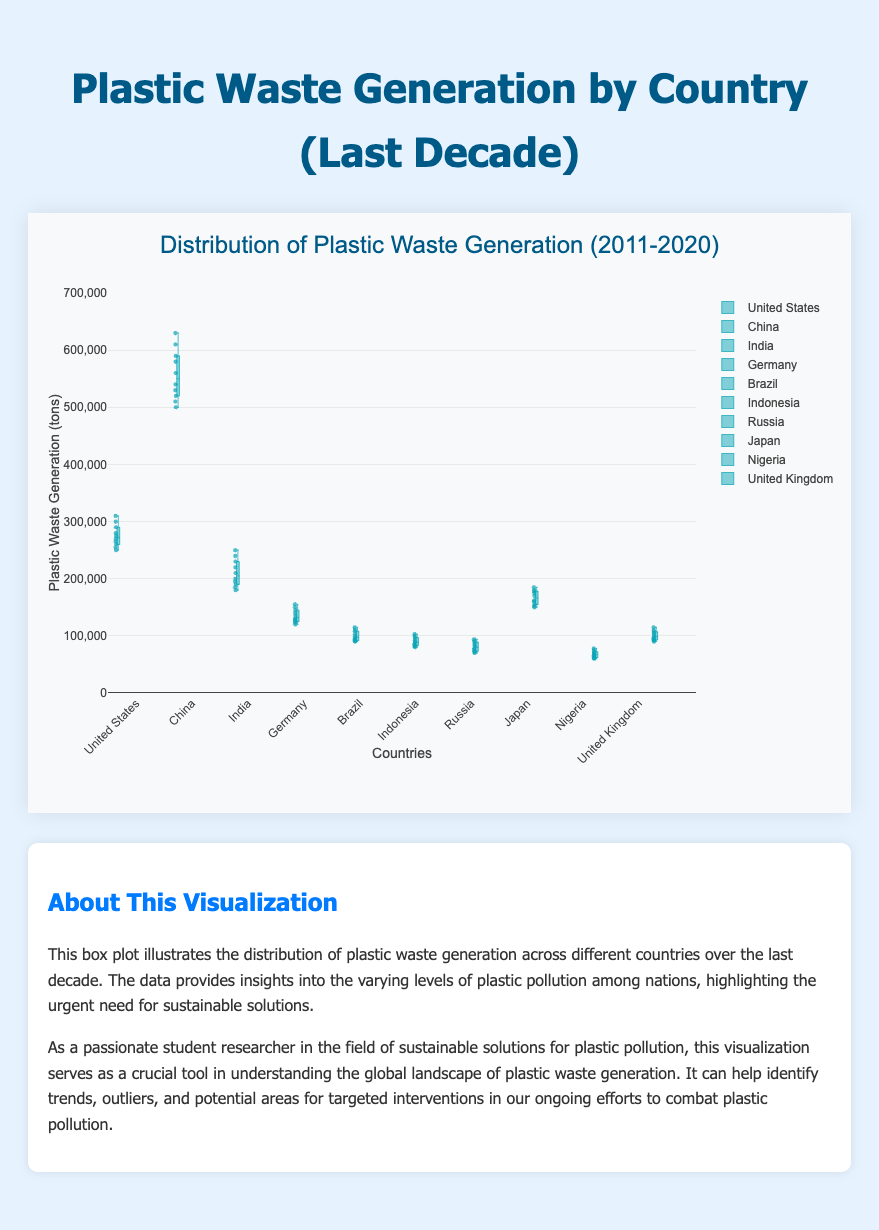what is the title of the chart? The title of the chart is displayed at the top of the figure. It provides a brief description of what is being shown. The title of the chart is "Distribution of Plastic Waste Generation (2011-2020)"
Answer: Distribution of Plastic Waste Generation (2011-2020) How many countries' plastic waste generation is represented in the chart? Each box plot in the chart represents data from one country. By counting the box plots or checking the names of countries on the x-axis, you can determine the total number. There are 10 countries represented in the chart.
Answer: 10 Which country has the highest median plastic waste generation? To find the country with the highest median plastic waste generation, you would look at the line inside each box plot which denotes the median value. China has the highest median plastic waste generation.
Answer: China What is the range of plastic waste generation in India? The range of plastic waste generation can be determined by looking at the bottom and top of the whiskers in the box plot for India. India's range is from 180,000 to 250,000 tons.
Answer: 180,000 to 250,000 tons Which country shows the least variation in plastic waste generation? The country with the least variation has the shortest height (smallest interquartile range) in its box plot. Germany shows the least variation in plastic waste generation.
Answer: Germany Compare the plastic waste generation in Brazil and the United Kingdom. Which country generates more plastic waste? By comparing the medians (the lines inside the boxes) or the overall range (whiskers and box) of the two countries, we can determine that the United Kingdom generates more plastic waste than Brazil.
Answer: United Kingdom What is the interquartile range (IQR) for Japan's plastic waste generation? The interquartile range is the difference between the upper quartile (75th percentile) and the lower quartile (25th percentile). For Japan, these values are roughly 180,000 and 155,000 tons respectively. Therefore, the IQR is 180,000 - 155,000 = 25,000 tons.
Answer: 25,000 tons Which country has the most outliers, and what are their values? Outliers are individual points plotted outside the whiskers of the box plot. Indonesia has the most outliers; here, the outliers are visible as points scattered above or below the whiskers. Indonesia's outliers are 103,000, 80,000, and 82,000 tons.
Answer: Indonesia (103,000, 80,000, 82,000 tons) Is there any country with a decreasing trend in plastic waste generation over the decade? By observing the position and trend of the points within each box plot, we can make an assessment. All countries shown demonstrate an increasing trend in plastic waste generation over the decade.
Answer: No 